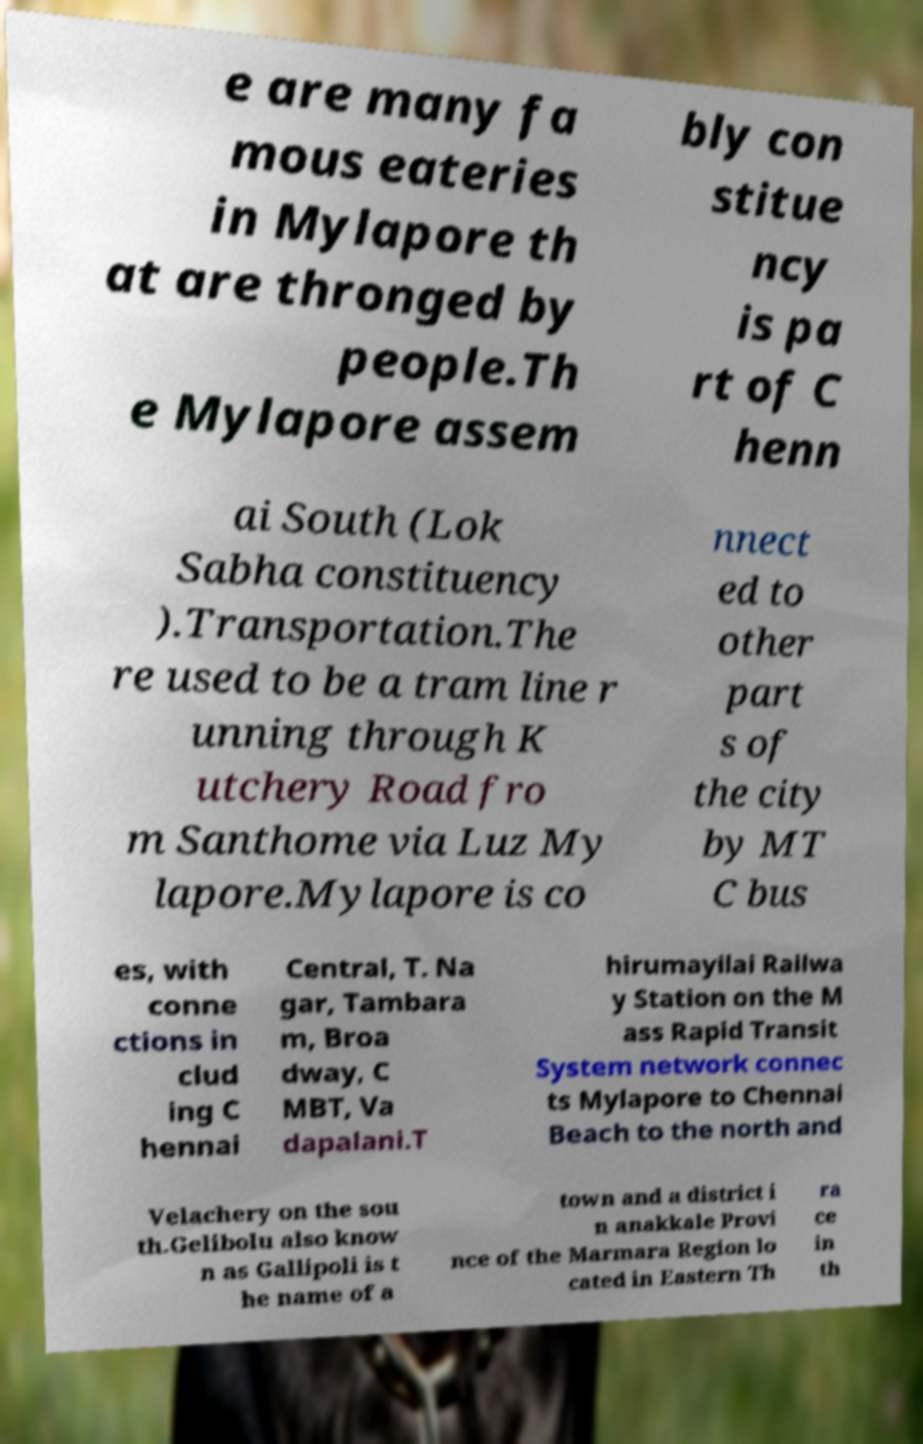Please read and relay the text visible in this image. What does it say? e are many fa mous eateries in Mylapore th at are thronged by people.Th e Mylapore assem bly con stitue ncy is pa rt of C henn ai South (Lok Sabha constituency ).Transportation.The re used to be a tram line r unning through K utchery Road fro m Santhome via Luz My lapore.Mylapore is co nnect ed to other part s of the city by MT C bus es, with conne ctions in clud ing C hennai Central, T. Na gar, Tambara m, Broa dway, C MBT, Va dapalani.T hirumayilai Railwa y Station on the M ass Rapid Transit System network connec ts Mylapore to Chennai Beach to the north and Velachery on the sou th.Gelibolu also know n as Gallipoli is t he name of a town and a district i n anakkale Provi nce of the Marmara Region lo cated in Eastern Th ra ce in th 